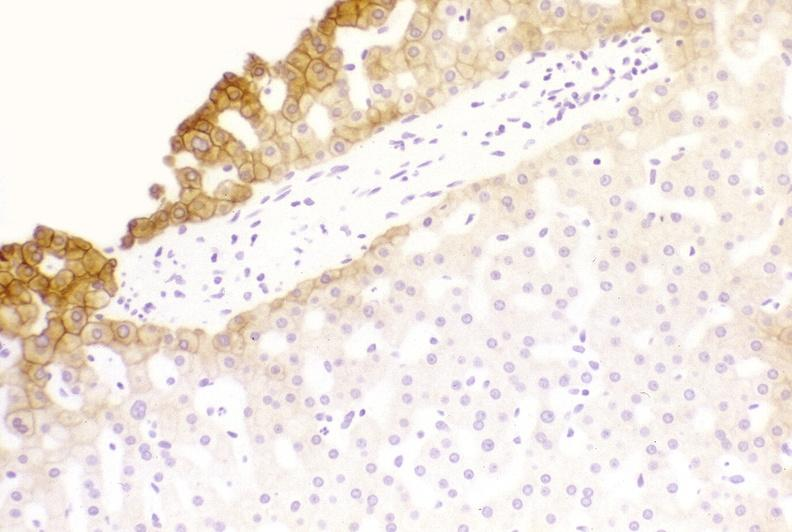s hepatobiliary present?
Answer the question using a single word or phrase. Yes 